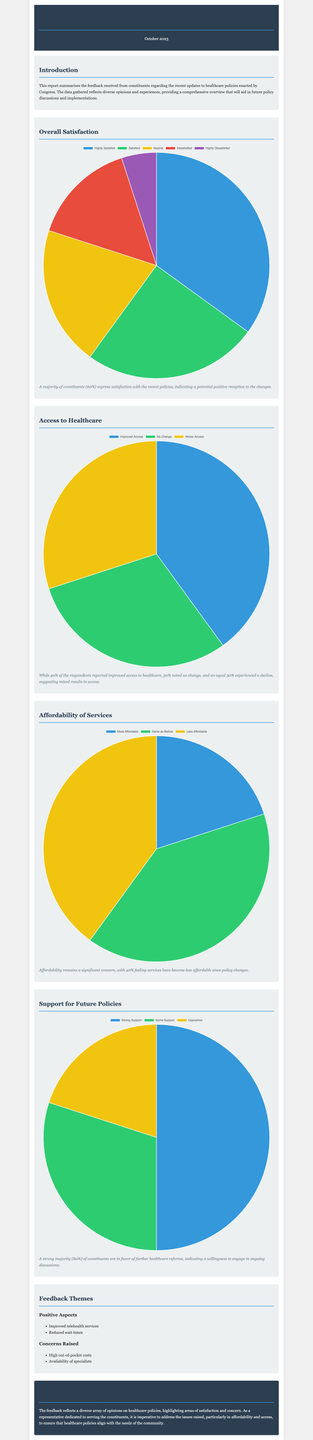What percentage of constituents express satisfaction with the recent policies? According to the report, 60% of constituents express satisfaction with the recent policies.
Answer: 60% What percentage of respondents reported improved access to healthcare? The document states that 40% of respondents reported improved access to healthcare.
Answer: 40% What is the main concern highlighted regarding affordability? The report mentions that 40% of constituents feel services have become less affordable.
Answer: Less affordable What percentage of constituents support further healthcare reforms? The report indicates that a strong majority, specifically 80%, are in favor of further healthcare reforms.
Answer: 80% What are the two positive aspects mentioned in the feedback themes? The positive aspects cited include improved telehealth services and reduced wait times.
Answer: Improved telehealth services, reduced wait times What are the two concerns raised in the feedback themes? The concerns raised are high out-of-pocket costs and availability of specialists.
Answer: High out-of-pocket costs, availability of specialists What is the title of the report? The report is titled "Constituents' Feedback on Recent Healthcare Policies."
Answer: Constituents' Feedback on Recent Healthcare Policies What conclusion is drawn regarding healthcare policies? The conclusion emphasizes the need to address issues raised, particularly in affordability and access.
Answer: Address affordability and access issues 